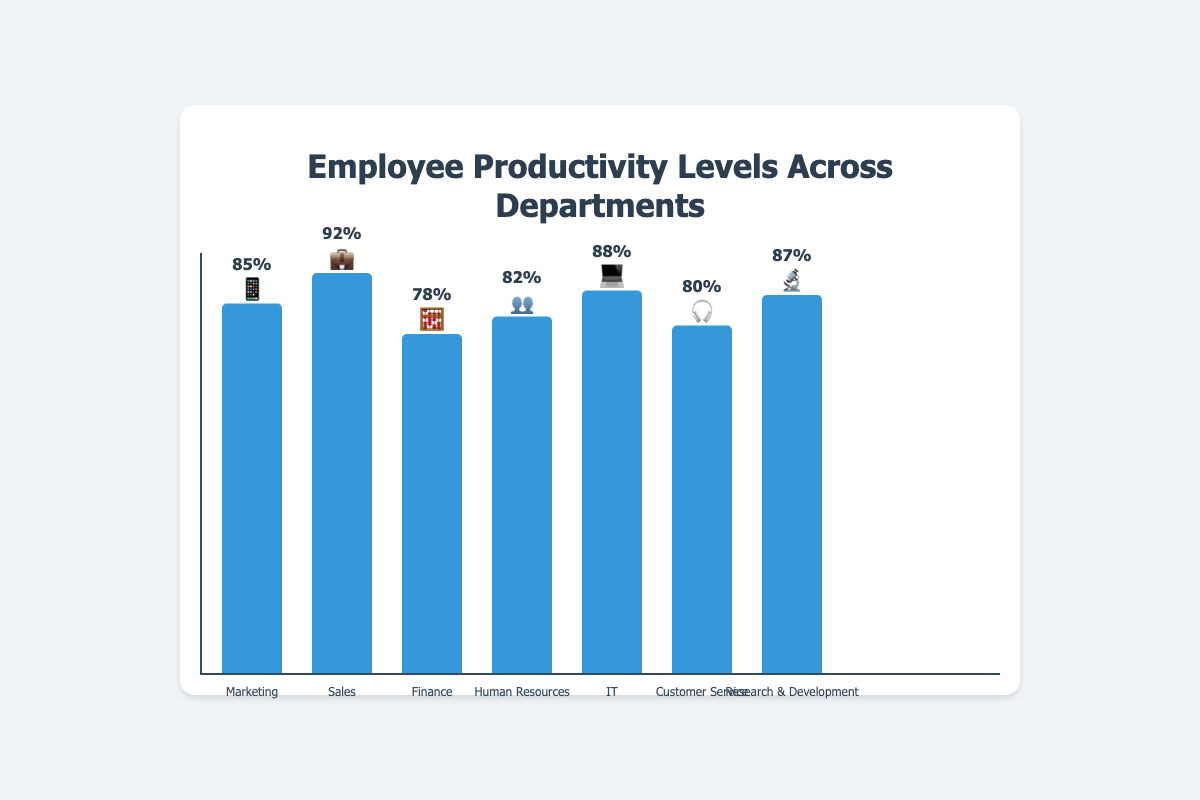How many departments are represented in the chart? Count the number of bars in the chart, which corresponds to the number of departments.
Answer: 7 Which department has the highest productivity level? Look for the bar that reaches the highest point on the y-axis and check the label and emoji associated with it.
Answer: Sales What is the productivity level of the IT department? Identify the bar labeled "IT" with the 💻 emoji and read the productivity percentage shown.
Answer: 88% Which department has the lowest productivity level and what is it? Find the shortest bar in the chart and check the label and percentage attached to it.
Answer: Finance, 78% How does the productivity of Marketing compare to that of Human Resources? Compare the heights and percentages of the bars labeled "Marketing" (📱) and "Human Resources" (👥).
Answer: Marketing is 3% higher What is the average productivity level of all departments? Sum the productivity levels of all departments (85 + 92 + 78 + 82 + 88 + 80 + 87) and divide by the number of departments (7).
Answer: Approximately 84.57% How much higher is the productivity in Sales compared to Customer Service? Subtract the productivity percentage of Customer Service (80) from that of Sales (92).
Answer: 12% What’s the median productivity level of the departments? Arrange the productivity levels in ascending order (78, 80, 82, 85, 87, 88, 92) and find the middle value.
Answer: 85% If the productivity of Finance increased by 5%, what would it be? Add 5% to the Finance department's current productivity level of 78%.
Answer: 83% Which departments have a productivity level of 80% or higher? List all departments whose bars reach at least the 80% mark on the y-axis.
Answer: Marketing, Sales, Human Resources, IT, Customer Service, Research & Development 